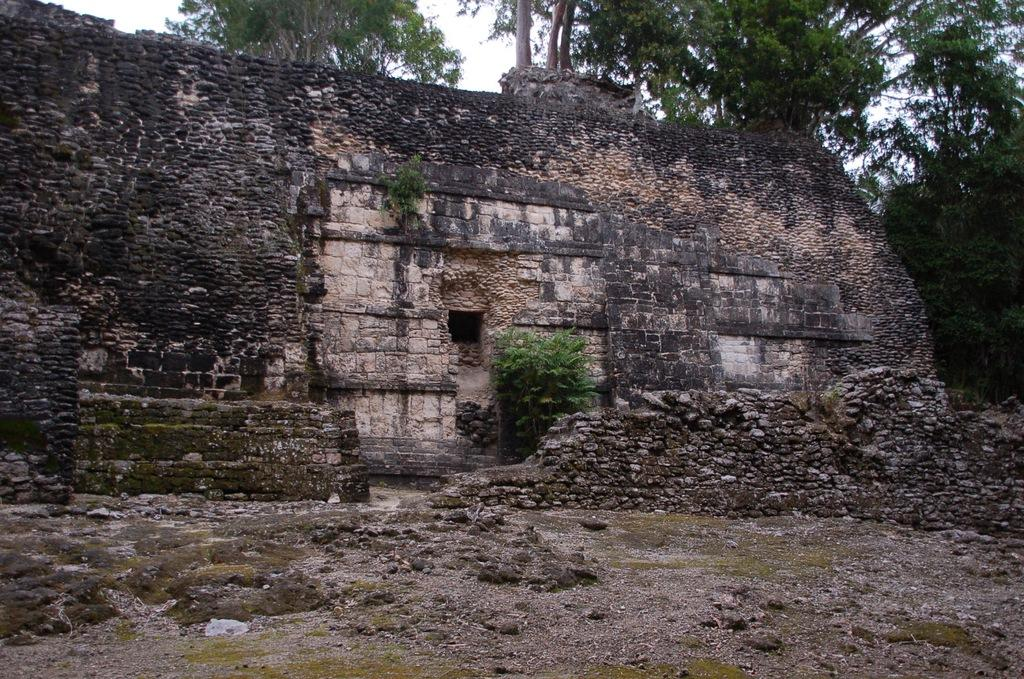What is the main subject in the center of the image? There is an old building in the center of the image. What can be seen in the background of the image? There are trees in the background of the image. What type of surface is visible at the bottom of the image? There is ground visible at the bottom of the image. What word is written on the cow in the image? There is no cow present in the image, so it is not possible to answer that question. 